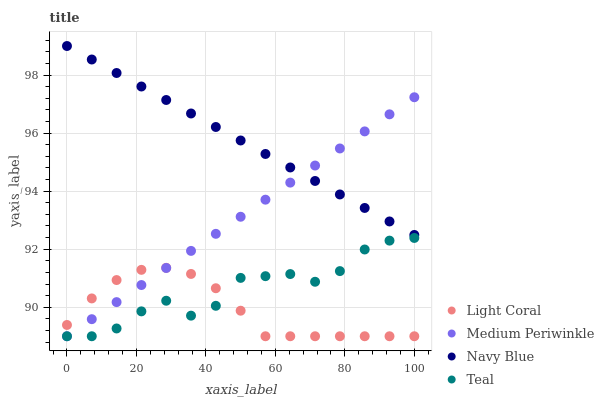Does Light Coral have the minimum area under the curve?
Answer yes or no. Yes. Does Navy Blue have the maximum area under the curve?
Answer yes or no. Yes. Does Medium Periwinkle have the minimum area under the curve?
Answer yes or no. No. Does Medium Periwinkle have the maximum area under the curve?
Answer yes or no. No. Is Medium Periwinkle the smoothest?
Answer yes or no. Yes. Is Teal the roughest?
Answer yes or no. Yes. Is Navy Blue the smoothest?
Answer yes or no. No. Is Navy Blue the roughest?
Answer yes or no. No. Does Light Coral have the lowest value?
Answer yes or no. Yes. Does Navy Blue have the lowest value?
Answer yes or no. No. Does Navy Blue have the highest value?
Answer yes or no. Yes. Does Medium Periwinkle have the highest value?
Answer yes or no. No. Is Teal less than Navy Blue?
Answer yes or no. Yes. Is Navy Blue greater than Light Coral?
Answer yes or no. Yes. Does Light Coral intersect Medium Periwinkle?
Answer yes or no. Yes. Is Light Coral less than Medium Periwinkle?
Answer yes or no. No. Is Light Coral greater than Medium Periwinkle?
Answer yes or no. No. Does Teal intersect Navy Blue?
Answer yes or no. No. 